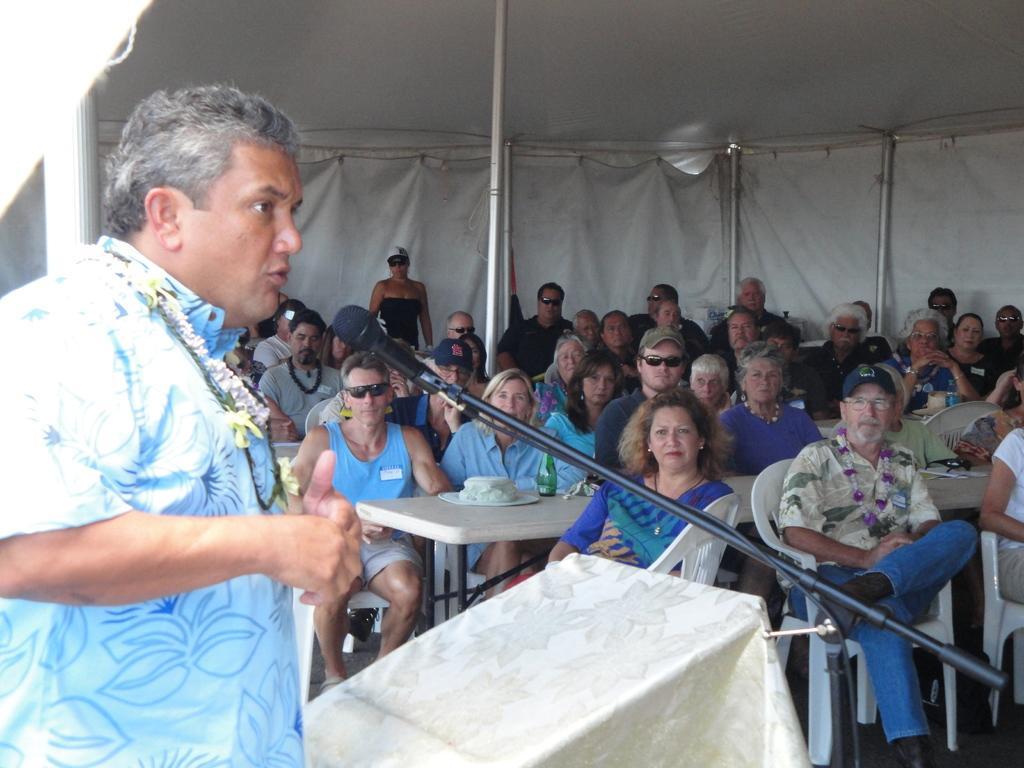How would you summarize this image in a sentence or two? In this image I can see a shed with curtains. And there are persons on the shed sits on the chair and the other person is standing. There is a table and on the table there is a plate, Cake and a bottle. And in front there is a mile and a desk covered with cloth. 